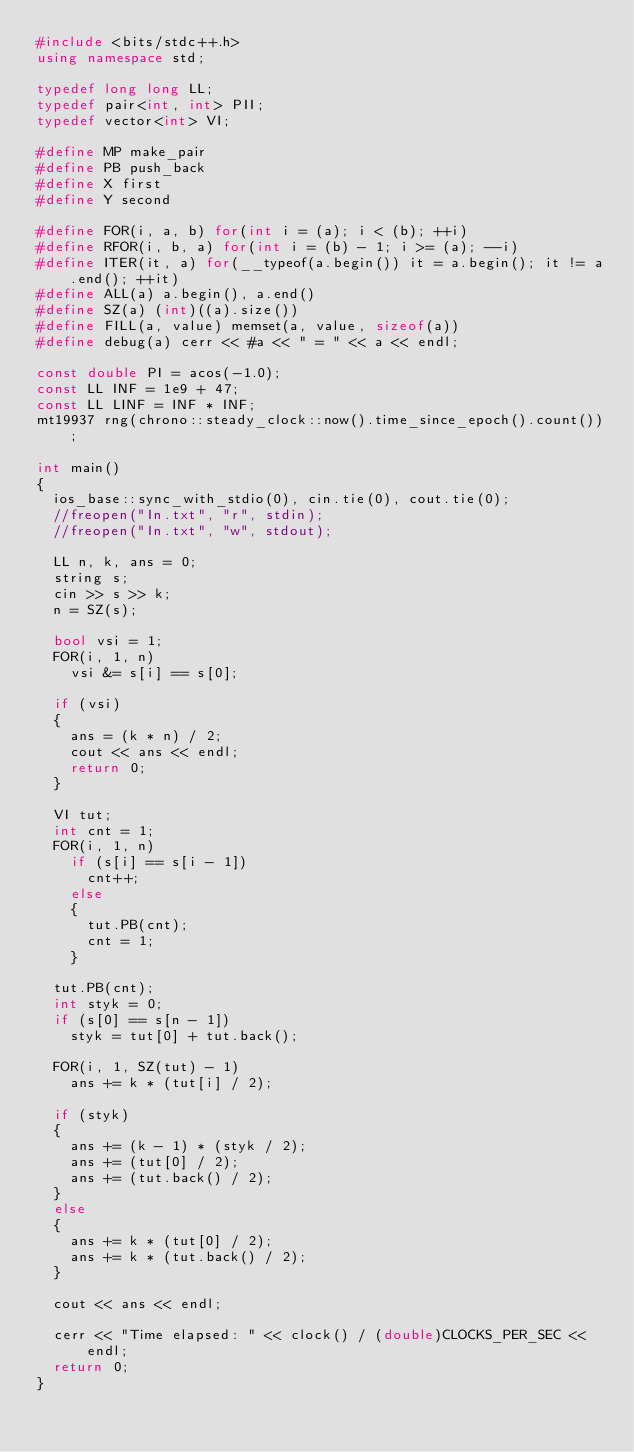Convert code to text. <code><loc_0><loc_0><loc_500><loc_500><_C++_>#include <bits/stdc++.h>
using namespace std;
 
typedef long long LL;
typedef pair<int, int> PII;
typedef vector<int> VI;

#define MP make_pair
#define PB push_back
#define X first
#define Y second
 
#define FOR(i, a, b) for(int i = (a); i < (b); ++i)
#define RFOR(i, b, a) for(int i = (b) - 1; i >= (a); --i)
#define ITER(it, a) for(__typeof(a.begin()) it = a.begin(); it != a.end(); ++it)
#define ALL(a) a.begin(), a.end()
#define SZ(a) (int)((a).size())
#define FILL(a, value) memset(a, value, sizeof(a))
#define debug(a) cerr << #a << " = " << a << endl;

const double PI = acos(-1.0);
const LL INF = 1e9 + 47;
const LL LINF = INF * INF;
mt19937 rng(chrono::steady_clock::now().time_since_epoch().count());

int main()
{
	ios_base::sync_with_stdio(0), cin.tie(0), cout.tie(0);
	//freopen("In.txt", "r", stdin);
	//freopen("In.txt", "w", stdout);
	
	LL n, k, ans = 0;
	string s;
	cin >> s >> k;
	n = SZ(s);
	
	bool vsi = 1;
	FOR(i, 1, n)
		vsi &= s[i] == s[0];
	
	if (vsi)
	{
		ans = (k * n) / 2;
		cout << ans << endl;
		return 0;
	}
	
	VI tut;
	int cnt = 1;
	FOR(i, 1, n)
		if (s[i] == s[i - 1])
			cnt++;
		else
		{
			tut.PB(cnt);
			cnt = 1;
		}
	
	tut.PB(cnt);
	int styk = 0;
	if (s[0] == s[n - 1])
		styk = tut[0] + tut.back();
	
	FOR(i, 1, SZ(tut) - 1)
		ans += k * (tut[i] / 2);
	
	if (styk)
	{
		ans += (k - 1) * (styk / 2);
		ans += (tut[0] / 2);
		ans += (tut.back() / 2);
	}
	else
	{
		ans += k * (tut[0] / 2);
		ans += k * (tut.back() / 2);
	}
	
	cout << ans << endl;
	
	cerr << "Time elapsed: " << clock() / (double)CLOCKS_PER_SEC << endl;
	return 0;
}
</code> 